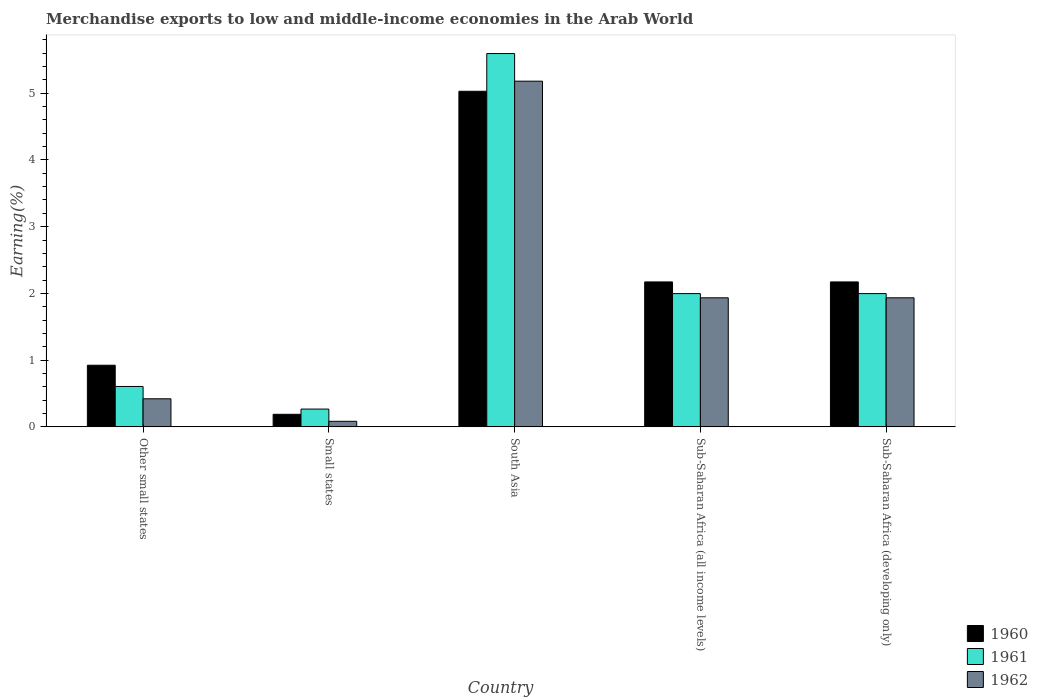How many different coloured bars are there?
Offer a very short reply. 3. Are the number of bars on each tick of the X-axis equal?
Your answer should be compact. Yes. What is the percentage of amount earned from merchandise exports in 1961 in Small states?
Provide a succinct answer. 0.27. Across all countries, what is the maximum percentage of amount earned from merchandise exports in 1962?
Offer a very short reply. 5.18. Across all countries, what is the minimum percentage of amount earned from merchandise exports in 1960?
Provide a short and direct response. 0.19. In which country was the percentage of amount earned from merchandise exports in 1961 minimum?
Your answer should be compact. Small states. What is the total percentage of amount earned from merchandise exports in 1960 in the graph?
Your answer should be compact. 10.48. What is the difference between the percentage of amount earned from merchandise exports in 1961 in Other small states and that in Sub-Saharan Africa (all income levels)?
Your answer should be very brief. -1.39. What is the difference between the percentage of amount earned from merchandise exports in 1961 in Small states and the percentage of amount earned from merchandise exports in 1962 in Other small states?
Ensure brevity in your answer.  -0.15. What is the average percentage of amount earned from merchandise exports in 1960 per country?
Make the answer very short. 2.1. What is the difference between the percentage of amount earned from merchandise exports of/in 1962 and percentage of amount earned from merchandise exports of/in 1961 in Other small states?
Ensure brevity in your answer.  -0.18. In how many countries, is the percentage of amount earned from merchandise exports in 1960 greater than 3.6 %?
Offer a very short reply. 1. What is the ratio of the percentage of amount earned from merchandise exports in 1962 in Other small states to that in South Asia?
Your answer should be compact. 0.08. Is the percentage of amount earned from merchandise exports in 1960 in Small states less than that in Sub-Saharan Africa (developing only)?
Offer a very short reply. Yes. Is the difference between the percentage of amount earned from merchandise exports in 1962 in South Asia and Sub-Saharan Africa (all income levels) greater than the difference between the percentage of amount earned from merchandise exports in 1961 in South Asia and Sub-Saharan Africa (all income levels)?
Make the answer very short. No. What is the difference between the highest and the second highest percentage of amount earned from merchandise exports in 1960?
Offer a terse response. -2.86. What is the difference between the highest and the lowest percentage of amount earned from merchandise exports in 1962?
Your response must be concise. 5.1. What does the 2nd bar from the right in Other small states represents?
Provide a short and direct response. 1961. Is it the case that in every country, the sum of the percentage of amount earned from merchandise exports in 1961 and percentage of amount earned from merchandise exports in 1960 is greater than the percentage of amount earned from merchandise exports in 1962?
Keep it short and to the point. Yes. How many bars are there?
Your response must be concise. 15. How many countries are there in the graph?
Provide a succinct answer. 5. Does the graph contain any zero values?
Your answer should be very brief. No. Does the graph contain grids?
Keep it short and to the point. No. How many legend labels are there?
Offer a terse response. 3. How are the legend labels stacked?
Ensure brevity in your answer.  Vertical. What is the title of the graph?
Provide a succinct answer. Merchandise exports to low and middle-income economies in the Arab World. Does "1980" appear as one of the legend labels in the graph?
Offer a very short reply. No. What is the label or title of the X-axis?
Give a very brief answer. Country. What is the label or title of the Y-axis?
Offer a very short reply. Earning(%). What is the Earning(%) of 1960 in Other small states?
Ensure brevity in your answer.  0.92. What is the Earning(%) of 1961 in Other small states?
Offer a very short reply. 0.61. What is the Earning(%) in 1962 in Other small states?
Keep it short and to the point. 0.42. What is the Earning(%) in 1960 in Small states?
Provide a short and direct response. 0.19. What is the Earning(%) of 1961 in Small states?
Provide a succinct answer. 0.27. What is the Earning(%) in 1962 in Small states?
Ensure brevity in your answer.  0.08. What is the Earning(%) of 1960 in South Asia?
Provide a succinct answer. 5.03. What is the Earning(%) in 1961 in South Asia?
Your answer should be very brief. 5.59. What is the Earning(%) in 1962 in South Asia?
Ensure brevity in your answer.  5.18. What is the Earning(%) of 1960 in Sub-Saharan Africa (all income levels)?
Your response must be concise. 2.17. What is the Earning(%) of 1961 in Sub-Saharan Africa (all income levels)?
Your response must be concise. 2. What is the Earning(%) of 1962 in Sub-Saharan Africa (all income levels)?
Offer a terse response. 1.93. What is the Earning(%) in 1960 in Sub-Saharan Africa (developing only)?
Keep it short and to the point. 2.17. What is the Earning(%) in 1961 in Sub-Saharan Africa (developing only)?
Ensure brevity in your answer.  2. What is the Earning(%) in 1962 in Sub-Saharan Africa (developing only)?
Provide a short and direct response. 1.93. Across all countries, what is the maximum Earning(%) of 1960?
Your answer should be very brief. 5.03. Across all countries, what is the maximum Earning(%) in 1961?
Your answer should be compact. 5.59. Across all countries, what is the maximum Earning(%) of 1962?
Give a very brief answer. 5.18. Across all countries, what is the minimum Earning(%) in 1960?
Your answer should be very brief. 0.19. Across all countries, what is the minimum Earning(%) in 1961?
Provide a succinct answer. 0.27. Across all countries, what is the minimum Earning(%) of 1962?
Provide a succinct answer. 0.08. What is the total Earning(%) of 1960 in the graph?
Your response must be concise. 10.48. What is the total Earning(%) in 1961 in the graph?
Keep it short and to the point. 10.46. What is the total Earning(%) of 1962 in the graph?
Give a very brief answer. 9.55. What is the difference between the Earning(%) of 1960 in Other small states and that in Small states?
Ensure brevity in your answer.  0.74. What is the difference between the Earning(%) of 1961 in Other small states and that in Small states?
Make the answer very short. 0.34. What is the difference between the Earning(%) in 1962 in Other small states and that in Small states?
Make the answer very short. 0.34. What is the difference between the Earning(%) of 1960 in Other small states and that in South Asia?
Provide a short and direct response. -4.1. What is the difference between the Earning(%) in 1961 in Other small states and that in South Asia?
Offer a very short reply. -4.99. What is the difference between the Earning(%) in 1962 in Other small states and that in South Asia?
Provide a succinct answer. -4.76. What is the difference between the Earning(%) of 1960 in Other small states and that in Sub-Saharan Africa (all income levels)?
Provide a short and direct response. -1.25. What is the difference between the Earning(%) in 1961 in Other small states and that in Sub-Saharan Africa (all income levels)?
Offer a very short reply. -1.39. What is the difference between the Earning(%) in 1962 in Other small states and that in Sub-Saharan Africa (all income levels)?
Offer a very short reply. -1.51. What is the difference between the Earning(%) of 1960 in Other small states and that in Sub-Saharan Africa (developing only)?
Provide a succinct answer. -1.25. What is the difference between the Earning(%) of 1961 in Other small states and that in Sub-Saharan Africa (developing only)?
Make the answer very short. -1.39. What is the difference between the Earning(%) of 1962 in Other small states and that in Sub-Saharan Africa (developing only)?
Your response must be concise. -1.51. What is the difference between the Earning(%) in 1960 in Small states and that in South Asia?
Your answer should be very brief. -4.84. What is the difference between the Earning(%) in 1961 in Small states and that in South Asia?
Keep it short and to the point. -5.33. What is the difference between the Earning(%) in 1962 in Small states and that in South Asia?
Your response must be concise. -5.1. What is the difference between the Earning(%) in 1960 in Small states and that in Sub-Saharan Africa (all income levels)?
Your response must be concise. -1.98. What is the difference between the Earning(%) in 1961 in Small states and that in Sub-Saharan Africa (all income levels)?
Make the answer very short. -1.73. What is the difference between the Earning(%) in 1962 in Small states and that in Sub-Saharan Africa (all income levels)?
Give a very brief answer. -1.85. What is the difference between the Earning(%) in 1960 in Small states and that in Sub-Saharan Africa (developing only)?
Ensure brevity in your answer.  -1.98. What is the difference between the Earning(%) of 1961 in Small states and that in Sub-Saharan Africa (developing only)?
Your answer should be very brief. -1.73. What is the difference between the Earning(%) of 1962 in Small states and that in Sub-Saharan Africa (developing only)?
Give a very brief answer. -1.85. What is the difference between the Earning(%) in 1960 in South Asia and that in Sub-Saharan Africa (all income levels)?
Provide a succinct answer. 2.86. What is the difference between the Earning(%) in 1961 in South Asia and that in Sub-Saharan Africa (all income levels)?
Ensure brevity in your answer.  3.6. What is the difference between the Earning(%) in 1962 in South Asia and that in Sub-Saharan Africa (all income levels)?
Give a very brief answer. 3.25. What is the difference between the Earning(%) in 1960 in South Asia and that in Sub-Saharan Africa (developing only)?
Your response must be concise. 2.86. What is the difference between the Earning(%) in 1961 in South Asia and that in Sub-Saharan Africa (developing only)?
Your answer should be compact. 3.6. What is the difference between the Earning(%) in 1962 in South Asia and that in Sub-Saharan Africa (developing only)?
Offer a very short reply. 3.25. What is the difference between the Earning(%) in 1960 in Other small states and the Earning(%) in 1961 in Small states?
Your response must be concise. 0.66. What is the difference between the Earning(%) of 1960 in Other small states and the Earning(%) of 1962 in Small states?
Ensure brevity in your answer.  0.84. What is the difference between the Earning(%) of 1961 in Other small states and the Earning(%) of 1962 in Small states?
Give a very brief answer. 0.52. What is the difference between the Earning(%) of 1960 in Other small states and the Earning(%) of 1961 in South Asia?
Give a very brief answer. -4.67. What is the difference between the Earning(%) of 1960 in Other small states and the Earning(%) of 1962 in South Asia?
Keep it short and to the point. -4.26. What is the difference between the Earning(%) in 1961 in Other small states and the Earning(%) in 1962 in South Asia?
Offer a very short reply. -4.57. What is the difference between the Earning(%) in 1960 in Other small states and the Earning(%) in 1961 in Sub-Saharan Africa (all income levels)?
Ensure brevity in your answer.  -1.07. What is the difference between the Earning(%) in 1960 in Other small states and the Earning(%) in 1962 in Sub-Saharan Africa (all income levels)?
Your answer should be compact. -1.01. What is the difference between the Earning(%) in 1961 in Other small states and the Earning(%) in 1962 in Sub-Saharan Africa (all income levels)?
Provide a succinct answer. -1.33. What is the difference between the Earning(%) in 1960 in Other small states and the Earning(%) in 1961 in Sub-Saharan Africa (developing only)?
Keep it short and to the point. -1.07. What is the difference between the Earning(%) of 1960 in Other small states and the Earning(%) of 1962 in Sub-Saharan Africa (developing only)?
Give a very brief answer. -1.01. What is the difference between the Earning(%) in 1961 in Other small states and the Earning(%) in 1962 in Sub-Saharan Africa (developing only)?
Provide a succinct answer. -1.33. What is the difference between the Earning(%) in 1960 in Small states and the Earning(%) in 1961 in South Asia?
Your answer should be very brief. -5.41. What is the difference between the Earning(%) in 1960 in Small states and the Earning(%) in 1962 in South Asia?
Provide a short and direct response. -4.99. What is the difference between the Earning(%) in 1961 in Small states and the Earning(%) in 1962 in South Asia?
Provide a short and direct response. -4.91. What is the difference between the Earning(%) in 1960 in Small states and the Earning(%) in 1961 in Sub-Saharan Africa (all income levels)?
Provide a succinct answer. -1.81. What is the difference between the Earning(%) in 1960 in Small states and the Earning(%) in 1962 in Sub-Saharan Africa (all income levels)?
Give a very brief answer. -1.75. What is the difference between the Earning(%) in 1961 in Small states and the Earning(%) in 1962 in Sub-Saharan Africa (all income levels)?
Provide a succinct answer. -1.67. What is the difference between the Earning(%) in 1960 in Small states and the Earning(%) in 1961 in Sub-Saharan Africa (developing only)?
Keep it short and to the point. -1.81. What is the difference between the Earning(%) of 1960 in Small states and the Earning(%) of 1962 in Sub-Saharan Africa (developing only)?
Your answer should be very brief. -1.75. What is the difference between the Earning(%) in 1961 in Small states and the Earning(%) in 1962 in Sub-Saharan Africa (developing only)?
Offer a very short reply. -1.67. What is the difference between the Earning(%) of 1960 in South Asia and the Earning(%) of 1961 in Sub-Saharan Africa (all income levels)?
Make the answer very short. 3.03. What is the difference between the Earning(%) of 1960 in South Asia and the Earning(%) of 1962 in Sub-Saharan Africa (all income levels)?
Offer a very short reply. 3.09. What is the difference between the Earning(%) of 1961 in South Asia and the Earning(%) of 1962 in Sub-Saharan Africa (all income levels)?
Give a very brief answer. 3.66. What is the difference between the Earning(%) in 1960 in South Asia and the Earning(%) in 1961 in Sub-Saharan Africa (developing only)?
Your answer should be very brief. 3.03. What is the difference between the Earning(%) of 1960 in South Asia and the Earning(%) of 1962 in Sub-Saharan Africa (developing only)?
Your response must be concise. 3.09. What is the difference between the Earning(%) in 1961 in South Asia and the Earning(%) in 1962 in Sub-Saharan Africa (developing only)?
Provide a short and direct response. 3.66. What is the difference between the Earning(%) in 1960 in Sub-Saharan Africa (all income levels) and the Earning(%) in 1961 in Sub-Saharan Africa (developing only)?
Offer a terse response. 0.18. What is the difference between the Earning(%) of 1960 in Sub-Saharan Africa (all income levels) and the Earning(%) of 1962 in Sub-Saharan Africa (developing only)?
Offer a terse response. 0.24. What is the difference between the Earning(%) of 1961 in Sub-Saharan Africa (all income levels) and the Earning(%) of 1962 in Sub-Saharan Africa (developing only)?
Offer a terse response. 0.06. What is the average Earning(%) in 1960 per country?
Your answer should be very brief. 2.1. What is the average Earning(%) of 1961 per country?
Provide a succinct answer. 2.09. What is the average Earning(%) in 1962 per country?
Your answer should be compact. 1.91. What is the difference between the Earning(%) in 1960 and Earning(%) in 1961 in Other small states?
Your response must be concise. 0.32. What is the difference between the Earning(%) of 1960 and Earning(%) of 1962 in Other small states?
Your answer should be very brief. 0.5. What is the difference between the Earning(%) in 1961 and Earning(%) in 1962 in Other small states?
Keep it short and to the point. 0.18. What is the difference between the Earning(%) of 1960 and Earning(%) of 1961 in Small states?
Provide a short and direct response. -0.08. What is the difference between the Earning(%) in 1960 and Earning(%) in 1962 in Small states?
Make the answer very short. 0.11. What is the difference between the Earning(%) in 1961 and Earning(%) in 1962 in Small states?
Your response must be concise. 0.18. What is the difference between the Earning(%) in 1960 and Earning(%) in 1961 in South Asia?
Your answer should be compact. -0.57. What is the difference between the Earning(%) of 1960 and Earning(%) of 1962 in South Asia?
Ensure brevity in your answer.  -0.15. What is the difference between the Earning(%) of 1961 and Earning(%) of 1962 in South Asia?
Offer a terse response. 0.41. What is the difference between the Earning(%) of 1960 and Earning(%) of 1961 in Sub-Saharan Africa (all income levels)?
Your response must be concise. 0.18. What is the difference between the Earning(%) of 1960 and Earning(%) of 1962 in Sub-Saharan Africa (all income levels)?
Your response must be concise. 0.24. What is the difference between the Earning(%) in 1961 and Earning(%) in 1962 in Sub-Saharan Africa (all income levels)?
Provide a short and direct response. 0.06. What is the difference between the Earning(%) in 1960 and Earning(%) in 1961 in Sub-Saharan Africa (developing only)?
Ensure brevity in your answer.  0.18. What is the difference between the Earning(%) of 1960 and Earning(%) of 1962 in Sub-Saharan Africa (developing only)?
Provide a succinct answer. 0.24. What is the difference between the Earning(%) in 1961 and Earning(%) in 1962 in Sub-Saharan Africa (developing only)?
Offer a terse response. 0.06. What is the ratio of the Earning(%) of 1960 in Other small states to that in Small states?
Provide a succinct answer. 4.9. What is the ratio of the Earning(%) of 1961 in Other small states to that in Small states?
Give a very brief answer. 2.27. What is the ratio of the Earning(%) of 1962 in Other small states to that in Small states?
Provide a short and direct response. 5.05. What is the ratio of the Earning(%) of 1960 in Other small states to that in South Asia?
Offer a terse response. 0.18. What is the ratio of the Earning(%) in 1961 in Other small states to that in South Asia?
Your response must be concise. 0.11. What is the ratio of the Earning(%) in 1962 in Other small states to that in South Asia?
Provide a succinct answer. 0.08. What is the ratio of the Earning(%) in 1960 in Other small states to that in Sub-Saharan Africa (all income levels)?
Offer a very short reply. 0.43. What is the ratio of the Earning(%) of 1961 in Other small states to that in Sub-Saharan Africa (all income levels)?
Give a very brief answer. 0.3. What is the ratio of the Earning(%) in 1962 in Other small states to that in Sub-Saharan Africa (all income levels)?
Your answer should be very brief. 0.22. What is the ratio of the Earning(%) of 1960 in Other small states to that in Sub-Saharan Africa (developing only)?
Give a very brief answer. 0.43. What is the ratio of the Earning(%) of 1961 in Other small states to that in Sub-Saharan Africa (developing only)?
Make the answer very short. 0.3. What is the ratio of the Earning(%) in 1962 in Other small states to that in Sub-Saharan Africa (developing only)?
Your answer should be compact. 0.22. What is the ratio of the Earning(%) of 1960 in Small states to that in South Asia?
Make the answer very short. 0.04. What is the ratio of the Earning(%) in 1961 in Small states to that in South Asia?
Offer a terse response. 0.05. What is the ratio of the Earning(%) of 1962 in Small states to that in South Asia?
Give a very brief answer. 0.02. What is the ratio of the Earning(%) in 1960 in Small states to that in Sub-Saharan Africa (all income levels)?
Your answer should be very brief. 0.09. What is the ratio of the Earning(%) of 1961 in Small states to that in Sub-Saharan Africa (all income levels)?
Provide a short and direct response. 0.13. What is the ratio of the Earning(%) in 1962 in Small states to that in Sub-Saharan Africa (all income levels)?
Make the answer very short. 0.04. What is the ratio of the Earning(%) in 1960 in Small states to that in Sub-Saharan Africa (developing only)?
Provide a short and direct response. 0.09. What is the ratio of the Earning(%) of 1961 in Small states to that in Sub-Saharan Africa (developing only)?
Your response must be concise. 0.13. What is the ratio of the Earning(%) in 1962 in Small states to that in Sub-Saharan Africa (developing only)?
Make the answer very short. 0.04. What is the ratio of the Earning(%) in 1960 in South Asia to that in Sub-Saharan Africa (all income levels)?
Ensure brevity in your answer.  2.32. What is the ratio of the Earning(%) in 1961 in South Asia to that in Sub-Saharan Africa (all income levels)?
Provide a succinct answer. 2.8. What is the ratio of the Earning(%) in 1962 in South Asia to that in Sub-Saharan Africa (all income levels)?
Your response must be concise. 2.68. What is the ratio of the Earning(%) of 1960 in South Asia to that in Sub-Saharan Africa (developing only)?
Give a very brief answer. 2.32. What is the ratio of the Earning(%) in 1961 in South Asia to that in Sub-Saharan Africa (developing only)?
Make the answer very short. 2.8. What is the ratio of the Earning(%) in 1962 in South Asia to that in Sub-Saharan Africa (developing only)?
Your response must be concise. 2.68. What is the ratio of the Earning(%) of 1960 in Sub-Saharan Africa (all income levels) to that in Sub-Saharan Africa (developing only)?
Your response must be concise. 1. What is the ratio of the Earning(%) in 1961 in Sub-Saharan Africa (all income levels) to that in Sub-Saharan Africa (developing only)?
Your response must be concise. 1. What is the ratio of the Earning(%) of 1962 in Sub-Saharan Africa (all income levels) to that in Sub-Saharan Africa (developing only)?
Keep it short and to the point. 1. What is the difference between the highest and the second highest Earning(%) of 1960?
Your response must be concise. 2.86. What is the difference between the highest and the second highest Earning(%) of 1961?
Your answer should be very brief. 3.6. What is the difference between the highest and the second highest Earning(%) of 1962?
Make the answer very short. 3.25. What is the difference between the highest and the lowest Earning(%) in 1960?
Ensure brevity in your answer.  4.84. What is the difference between the highest and the lowest Earning(%) in 1961?
Ensure brevity in your answer.  5.33. What is the difference between the highest and the lowest Earning(%) in 1962?
Provide a succinct answer. 5.1. 